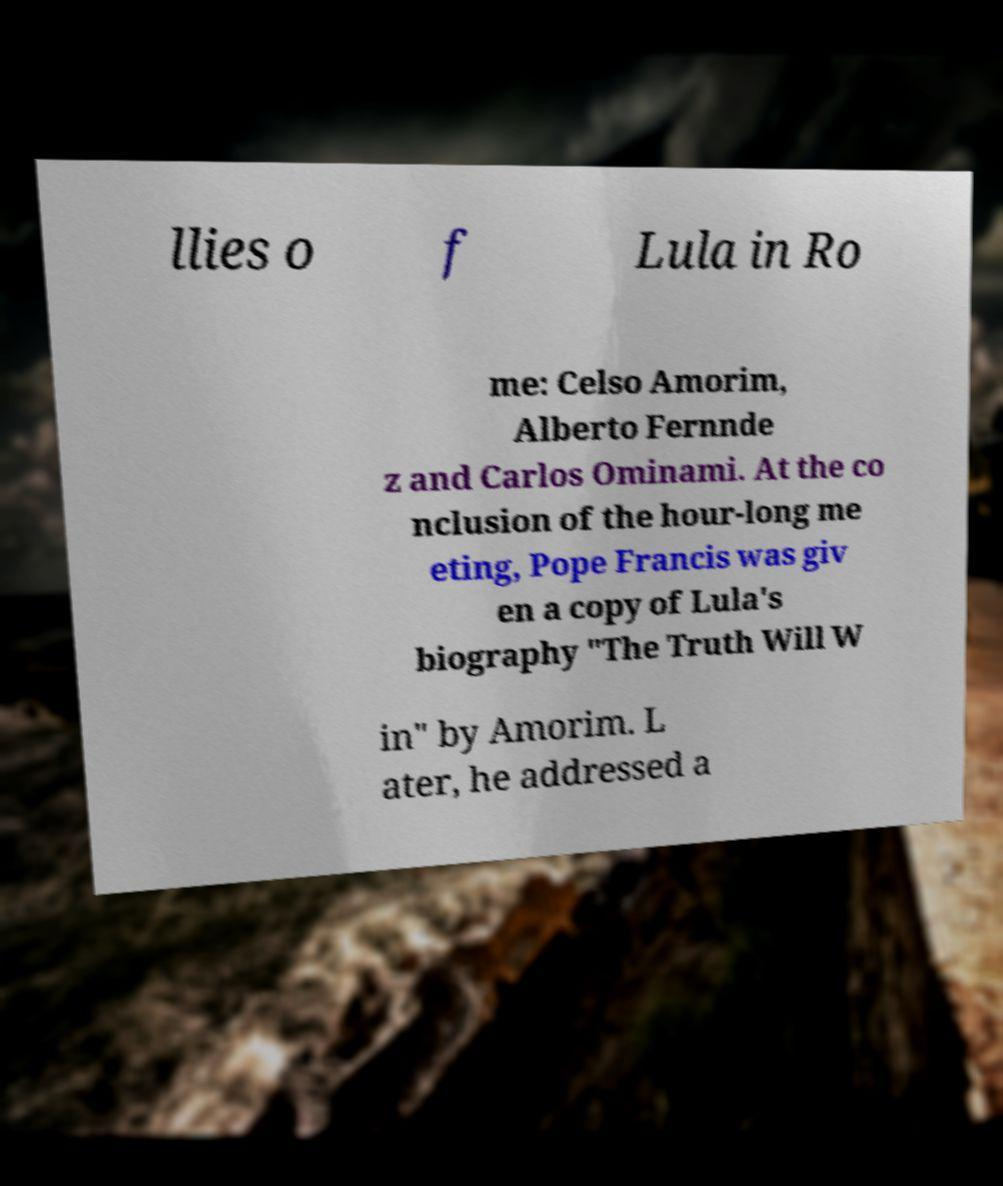Could you assist in decoding the text presented in this image and type it out clearly? llies o f Lula in Ro me: Celso Amorim, Alberto Fernnde z and Carlos Ominami. At the co nclusion of the hour-long me eting, Pope Francis was giv en a copy of Lula's biography "The Truth Will W in" by Amorim. L ater, he addressed a 